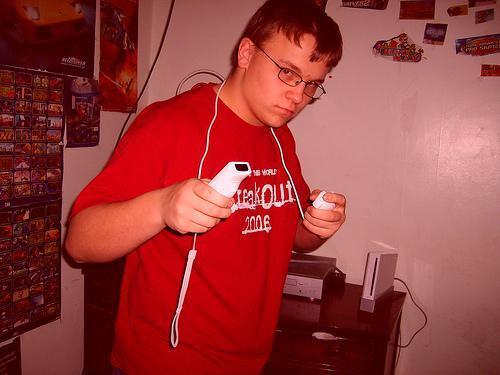How many red shirts are there?
Give a very brief answer. 1. 